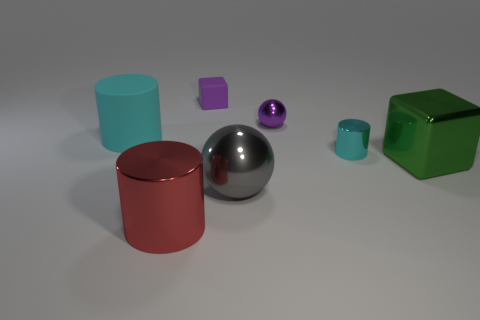How many cyan cylinders must be subtracted to get 1 cyan cylinders? 1 Subtract all gray balls. How many cyan cylinders are left? 2 Subtract 1 cylinders. How many cylinders are left? 2 Add 2 large red cylinders. How many objects exist? 9 Subtract all balls. How many objects are left? 5 Add 4 big metallic cylinders. How many big metallic cylinders are left? 5 Add 7 large blocks. How many large blocks exist? 8 Subtract 0 blue cylinders. How many objects are left? 7 Subtract all green metal objects. Subtract all yellow metal balls. How many objects are left? 6 